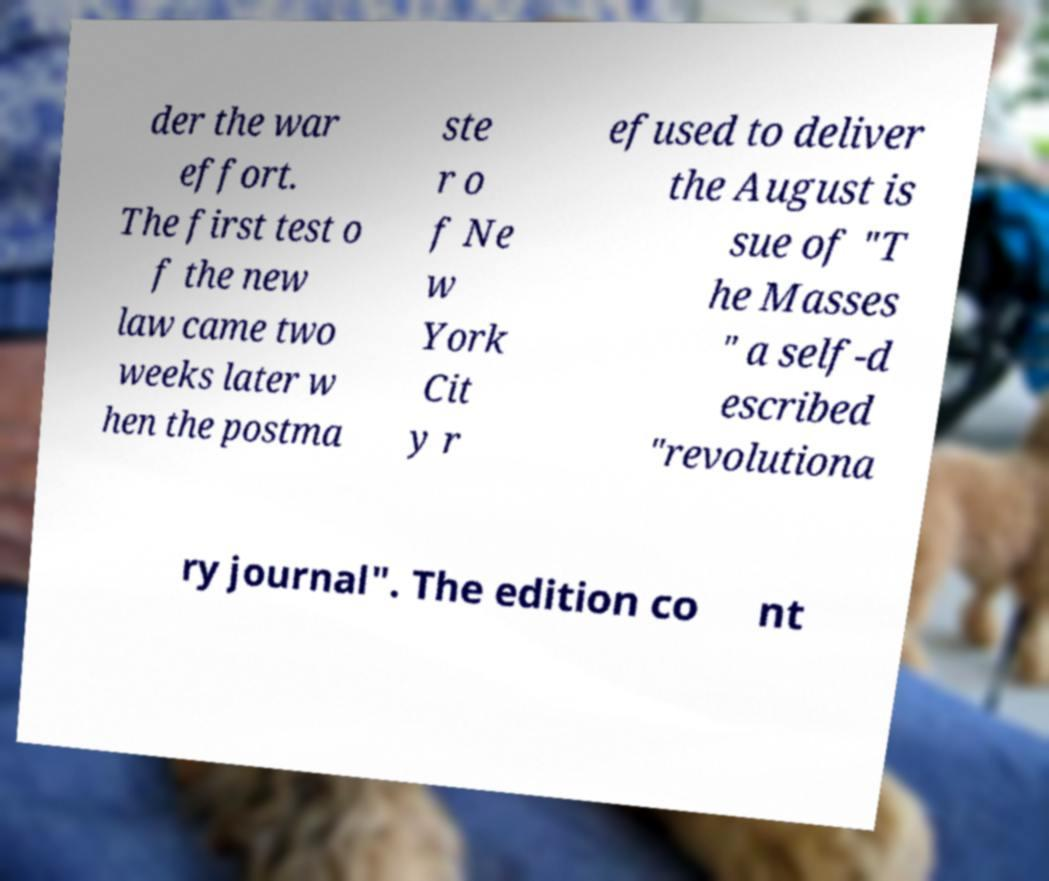For documentation purposes, I need the text within this image transcribed. Could you provide that? der the war effort. The first test o f the new law came two weeks later w hen the postma ste r o f Ne w York Cit y r efused to deliver the August is sue of "T he Masses " a self-d escribed "revolutiona ry journal". The edition co nt 